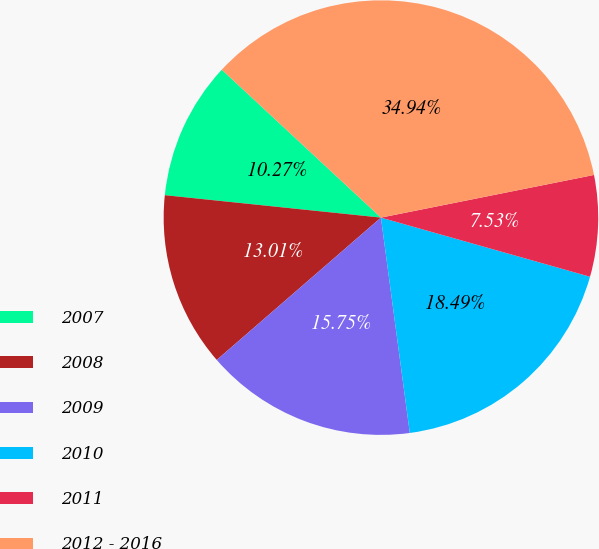Convert chart. <chart><loc_0><loc_0><loc_500><loc_500><pie_chart><fcel>2007<fcel>2008<fcel>2009<fcel>2010<fcel>2011<fcel>2012 - 2016<nl><fcel>10.27%<fcel>13.01%<fcel>15.75%<fcel>18.49%<fcel>7.53%<fcel>34.93%<nl></chart> 